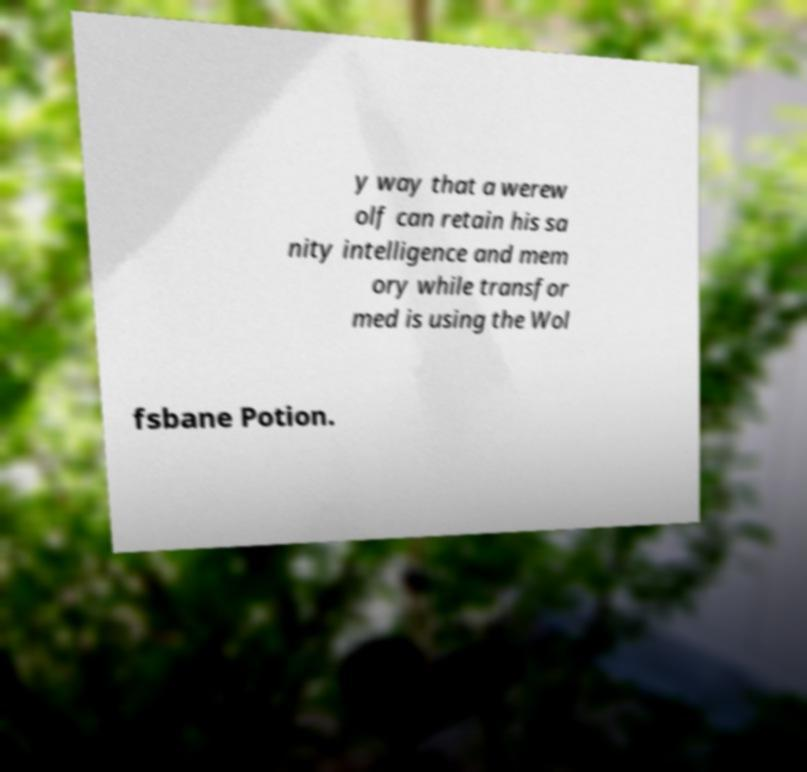Could you extract and type out the text from this image? y way that a werew olf can retain his sa nity intelligence and mem ory while transfor med is using the Wol fsbane Potion. 